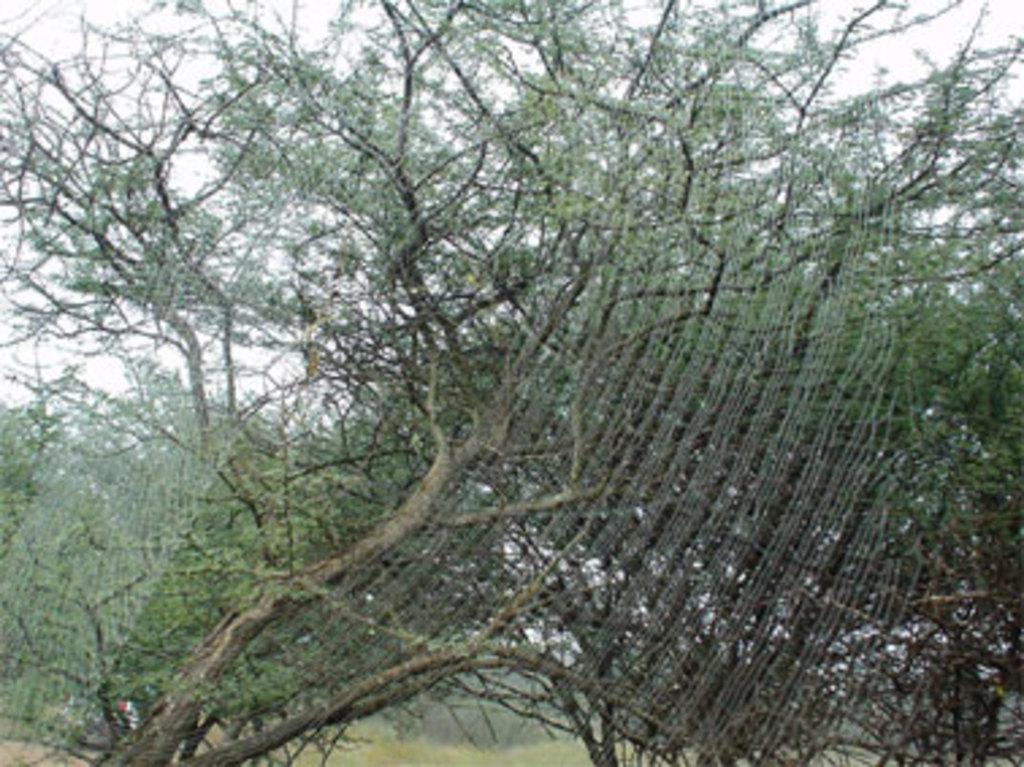What type of vegetation can be seen in the image? There are trees in the image. What is located in the foreground of the image? There is a spider web in the foreground of the image. What is visible at the top of the image? The sky is visible at the top of the image. What type of jelly is present in the image? There is no jelly present in the image. What message of peace can be seen in the image? There is no message of peace depicted in the image. 